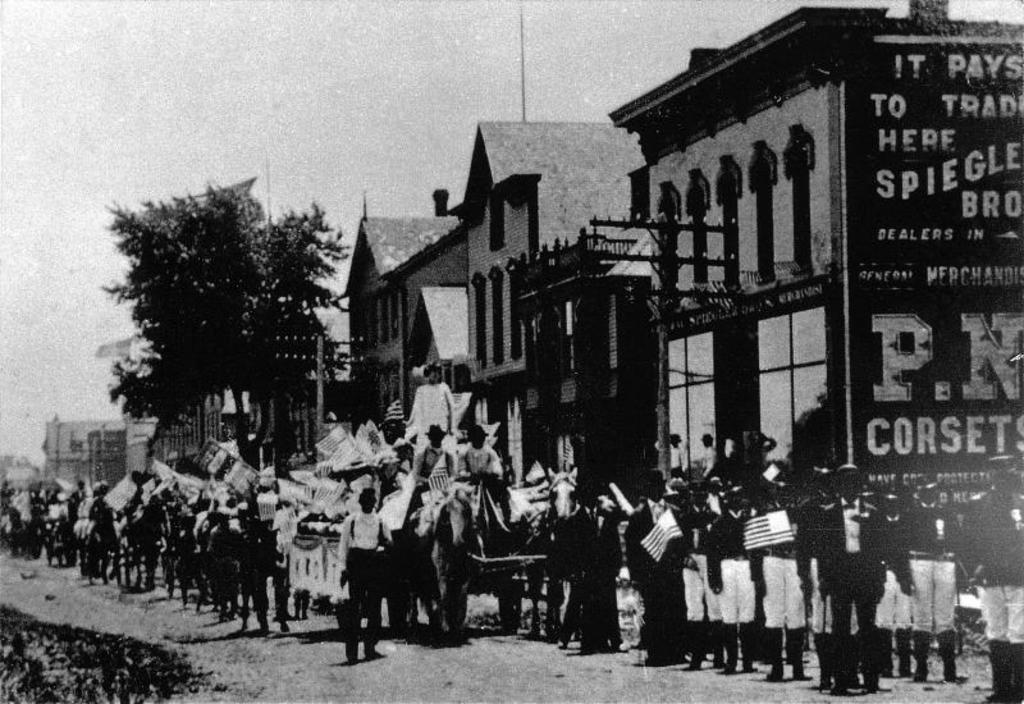Who or what is present in the image? There are people in the image. What are the people holding in the image? The people are holding flags. What can be seen in the background of the image? There are buildings, trees, and the sky visible in the background of the image. How many carts are being used to measure the grip of the trees in the image? There are no carts or any indication of measuring the grip of trees in the image. 